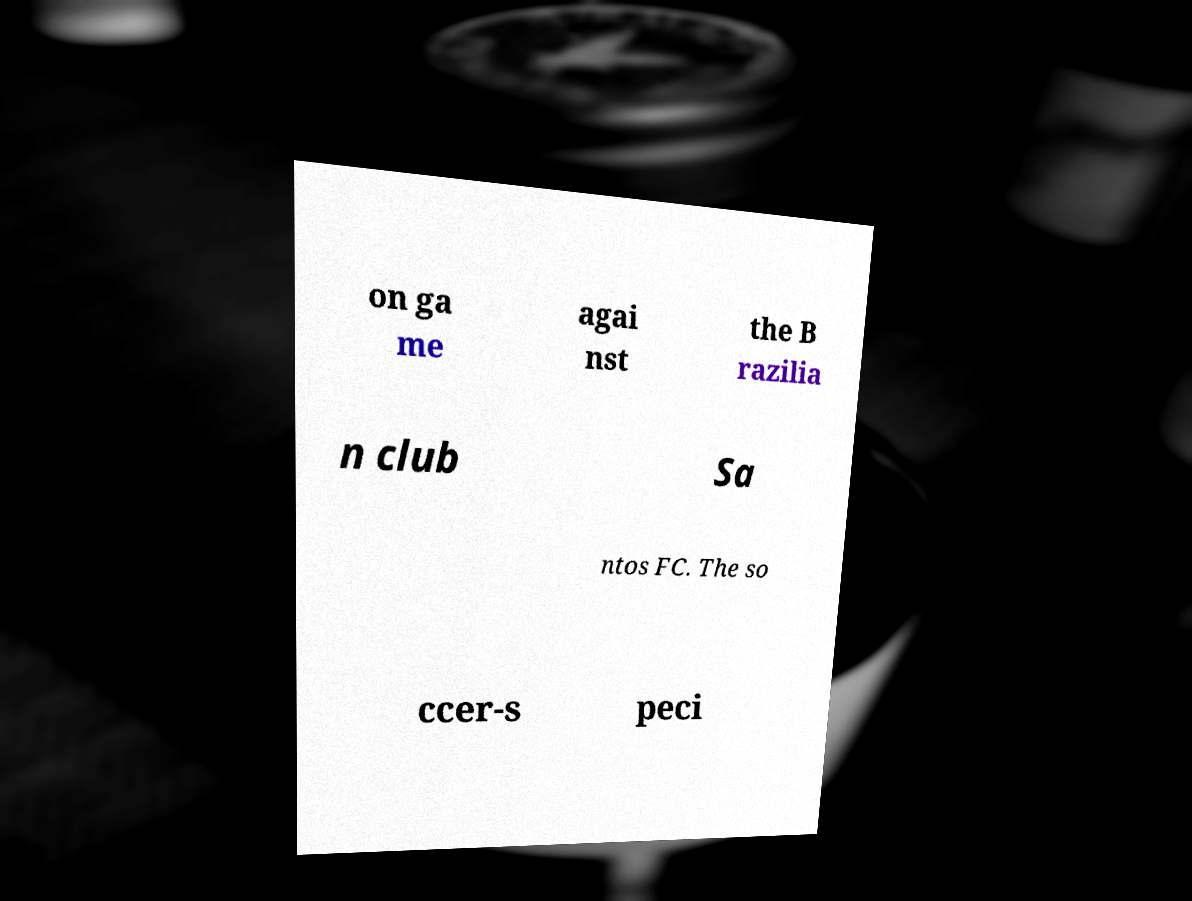Could you extract and type out the text from this image? on ga me agai nst the B razilia n club Sa ntos FC. The so ccer-s peci 